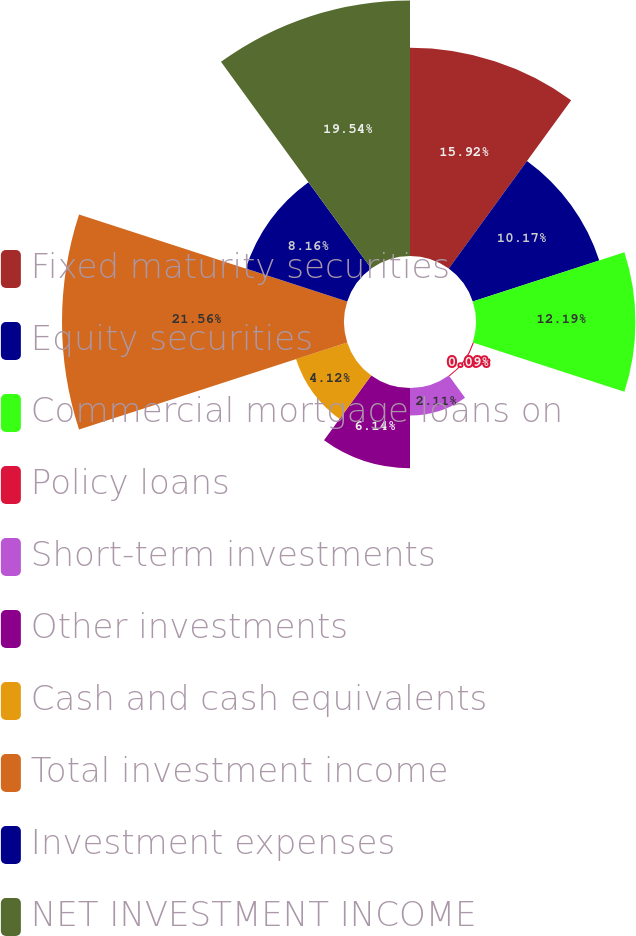Convert chart. <chart><loc_0><loc_0><loc_500><loc_500><pie_chart><fcel>Fixed maturity securities<fcel>Equity securities<fcel>Commercial mortgage loans on<fcel>Policy loans<fcel>Short-term investments<fcel>Other investments<fcel>Cash and cash equivalents<fcel>Total investment income<fcel>Investment expenses<fcel>NET INVESTMENT INCOME<nl><fcel>15.92%<fcel>10.17%<fcel>12.19%<fcel>0.09%<fcel>2.11%<fcel>6.14%<fcel>4.12%<fcel>21.56%<fcel>8.16%<fcel>19.54%<nl></chart> 